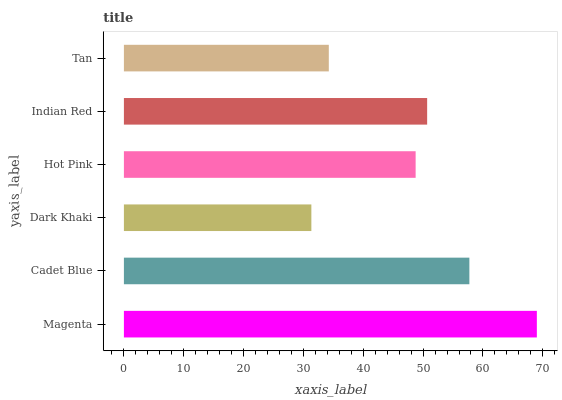Is Dark Khaki the minimum?
Answer yes or no. Yes. Is Magenta the maximum?
Answer yes or no. Yes. Is Cadet Blue the minimum?
Answer yes or no. No. Is Cadet Blue the maximum?
Answer yes or no. No. Is Magenta greater than Cadet Blue?
Answer yes or no. Yes. Is Cadet Blue less than Magenta?
Answer yes or no. Yes. Is Cadet Blue greater than Magenta?
Answer yes or no. No. Is Magenta less than Cadet Blue?
Answer yes or no. No. Is Indian Red the high median?
Answer yes or no. Yes. Is Hot Pink the low median?
Answer yes or no. Yes. Is Dark Khaki the high median?
Answer yes or no. No. Is Tan the low median?
Answer yes or no. No. 